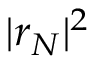<formula> <loc_0><loc_0><loc_500><loc_500>| r _ { N } | ^ { 2 }</formula> 